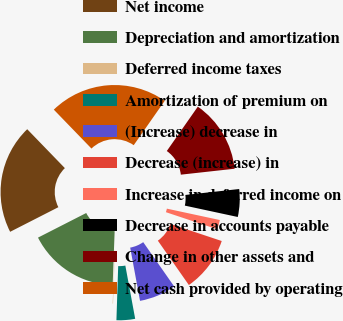<chart> <loc_0><loc_0><loc_500><loc_500><pie_chart><fcel>Net income<fcel>Depreciation and amortization<fcel>Deferred income taxes<fcel>Amortization of premium on<fcel>(Increase) decrease in<fcel>Decrease (increase) in<fcel>Increase in deferred income on<fcel>Decrease in accounts payable<fcel>Change in other assets and<fcel>Net cash provided by operating<nl><fcel>20.27%<fcel>16.9%<fcel>0.07%<fcel>3.43%<fcel>6.8%<fcel>10.17%<fcel>1.75%<fcel>5.12%<fcel>13.54%<fcel>21.95%<nl></chart> 